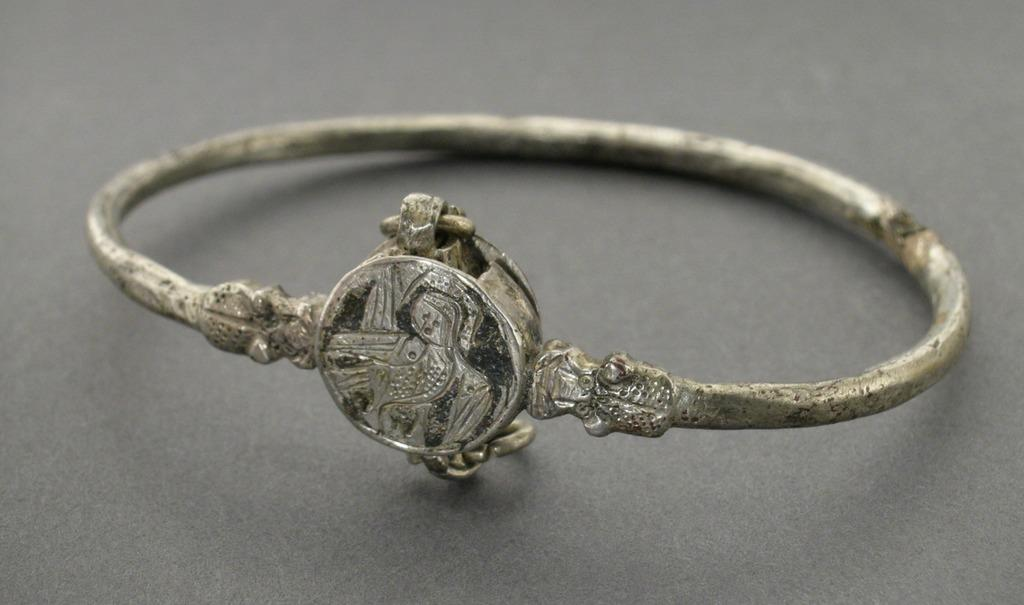What is the main object in the image? There is a ring in the image. What is the color of the surface the ring is on? The ring is on a black surface. How many strands of hair can be seen on the side of the tent in the image? There is no tent or hair present in the image; it only features a ring on a black surface. 